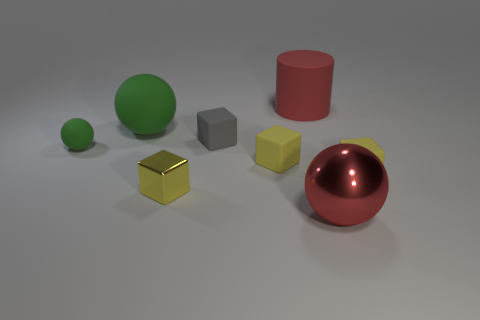Can you tell me the colors and shapes present in the image? Certainly! The image includes a spectrum of colors and shapes. There's a large red sphere and a large green sphere, a medium-sized yellow cube, a small grey cube, and a small green sphere. Additionally, there is a red matte cylinder and a golden metallic cube. Which is the largest object and what's its texture like? The largest object appears to be the red sphere with a shiny, reflective surface. Its glossy texture indicates that it's likely quite smooth. 